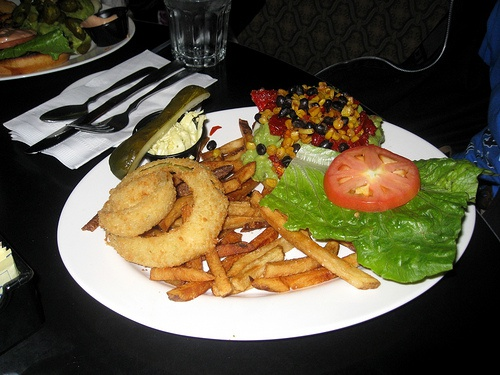Describe the objects in this image and their specific colors. I can see dining table in black, white, brown, and tan tones, cup in black, gray, purple, and darkgray tones, knife in black, gray, and darkgray tones, fork in black and gray tones, and spoon in black, gray, and darkgray tones in this image. 